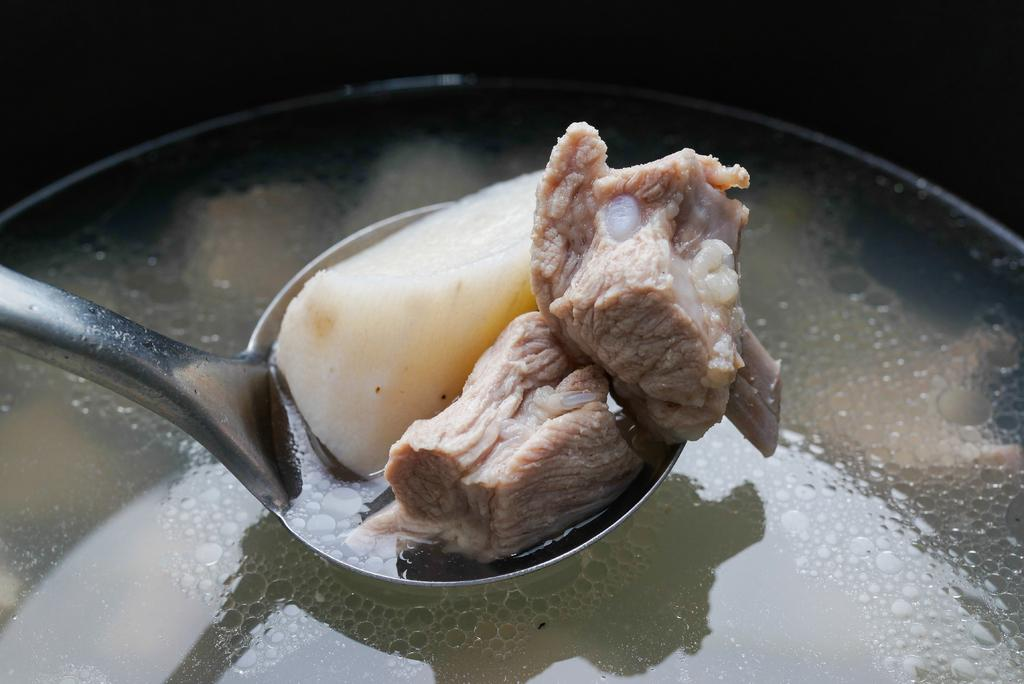What utensil is visible in the image? There is a spoon in the image. What type of food is present in the image? There is meat in the image. What else can be seen in the image besides the spoon and meat? There is liquid in the image. How would you describe the overall lighting or color of the image? The background of the image is dark. What page is the badge attached to in the image? There is no page or badge present in the image; it only contains a spoon, meat, and liquid. How many bites have been taken out of the meat in the image? There is no indication of any bites taken out of the meat in the image. 